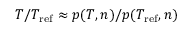Convert formula to latex. <formula><loc_0><loc_0><loc_500><loc_500>T / T _ { r e f } \approx p ( T , n ) / p ( T _ { r e f } , n )</formula> 